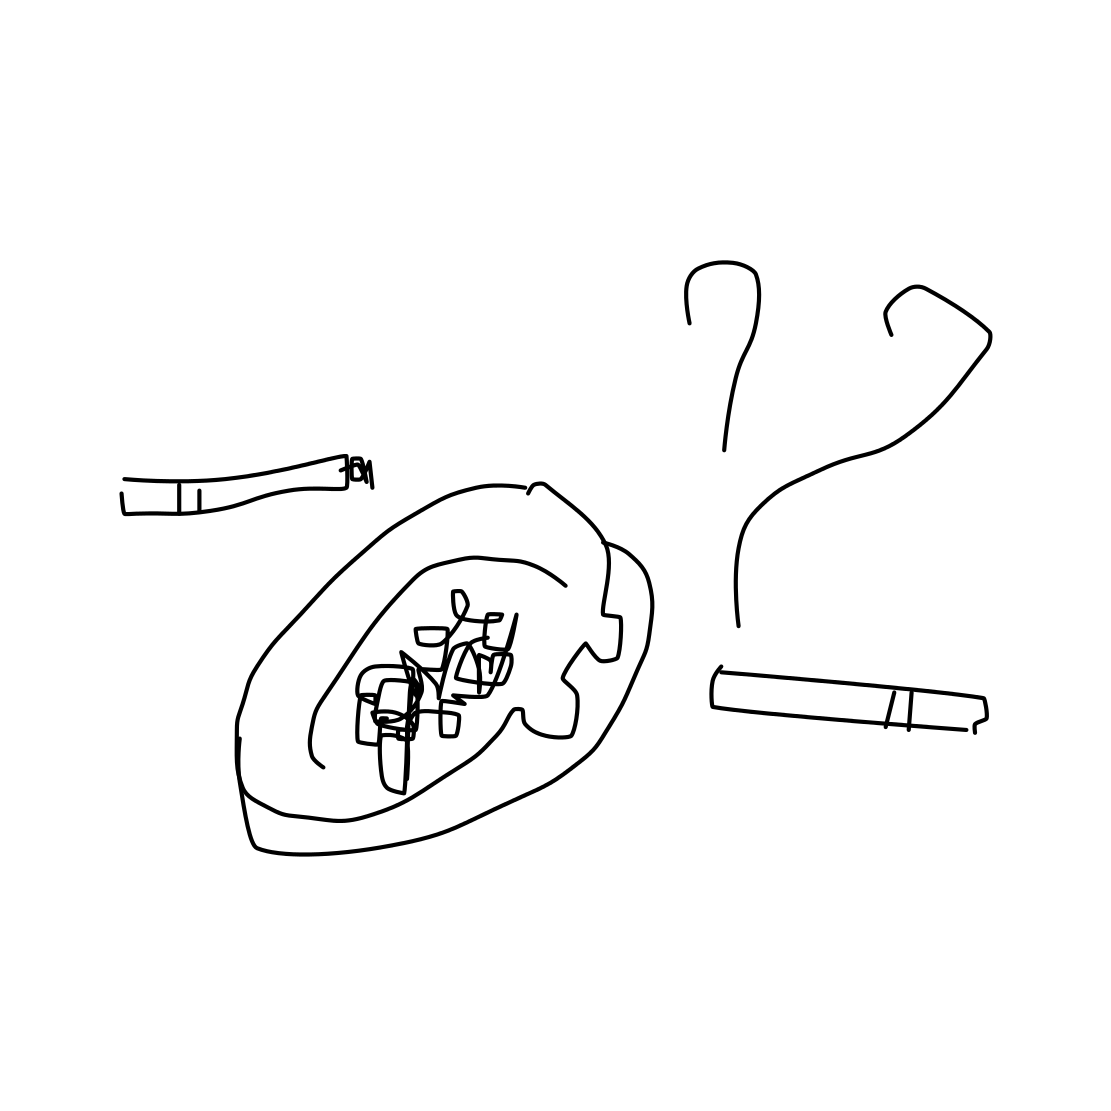What is the overall theme hinted at by the presence of cigarettes and an ashtray? The image suggests a theme of smoking habits or a smoking area, emphasizing the use of cigarettes. Could the scene be part of a larger narrative? Absolutely, this could be a snapshot from a social setting, like a break room or a personal space where someone frequents for smoke breaks, possibly reflecting on personal habits or social issues related to smoking. 